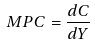Convert formula to latex. <formula><loc_0><loc_0><loc_500><loc_500>M P C = \frac { d C } { d Y }</formula> 